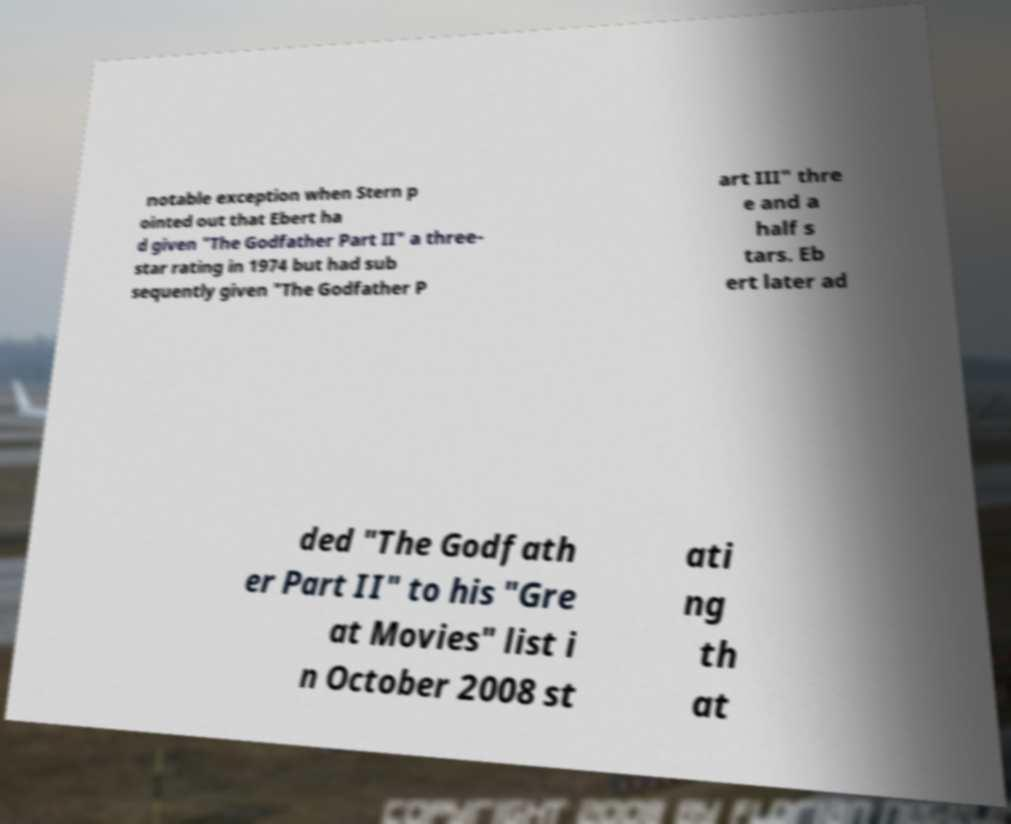Please identify and transcribe the text found in this image. notable exception when Stern p ointed out that Ebert ha d given "The Godfather Part II" a three- star rating in 1974 but had sub sequently given "The Godfather P art III" thre e and a half s tars. Eb ert later ad ded "The Godfath er Part II" to his "Gre at Movies" list i n October 2008 st ati ng th at 